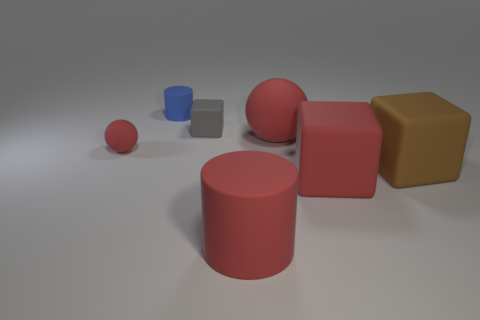There is a rubber cube that is the same color as the big matte cylinder; what size is it?
Your answer should be very brief. Large. What shape is the small thing to the right of the tiny blue matte cylinder?
Ensure brevity in your answer.  Cube. Is the color of the cylinder to the left of the tiny gray matte cube the same as the large matte cylinder?
Ensure brevity in your answer.  No. What is the material of the big cube that is the same color as the big cylinder?
Ensure brevity in your answer.  Rubber. Is the size of the cube that is on the left side of the red cube the same as the small red ball?
Your answer should be very brief. Yes. Are there any other balls of the same color as the big sphere?
Make the answer very short. Yes. There is a cube in front of the brown thing; is there a big red matte object that is behind it?
Your answer should be compact. Yes. Is there a small gray thing made of the same material as the large red ball?
Your answer should be compact. Yes. The red sphere that is to the right of the big thing in front of the big red matte cube is made of what material?
Provide a short and direct response. Rubber. What material is the block that is both in front of the big red rubber ball and left of the brown matte thing?
Provide a short and direct response. Rubber. 